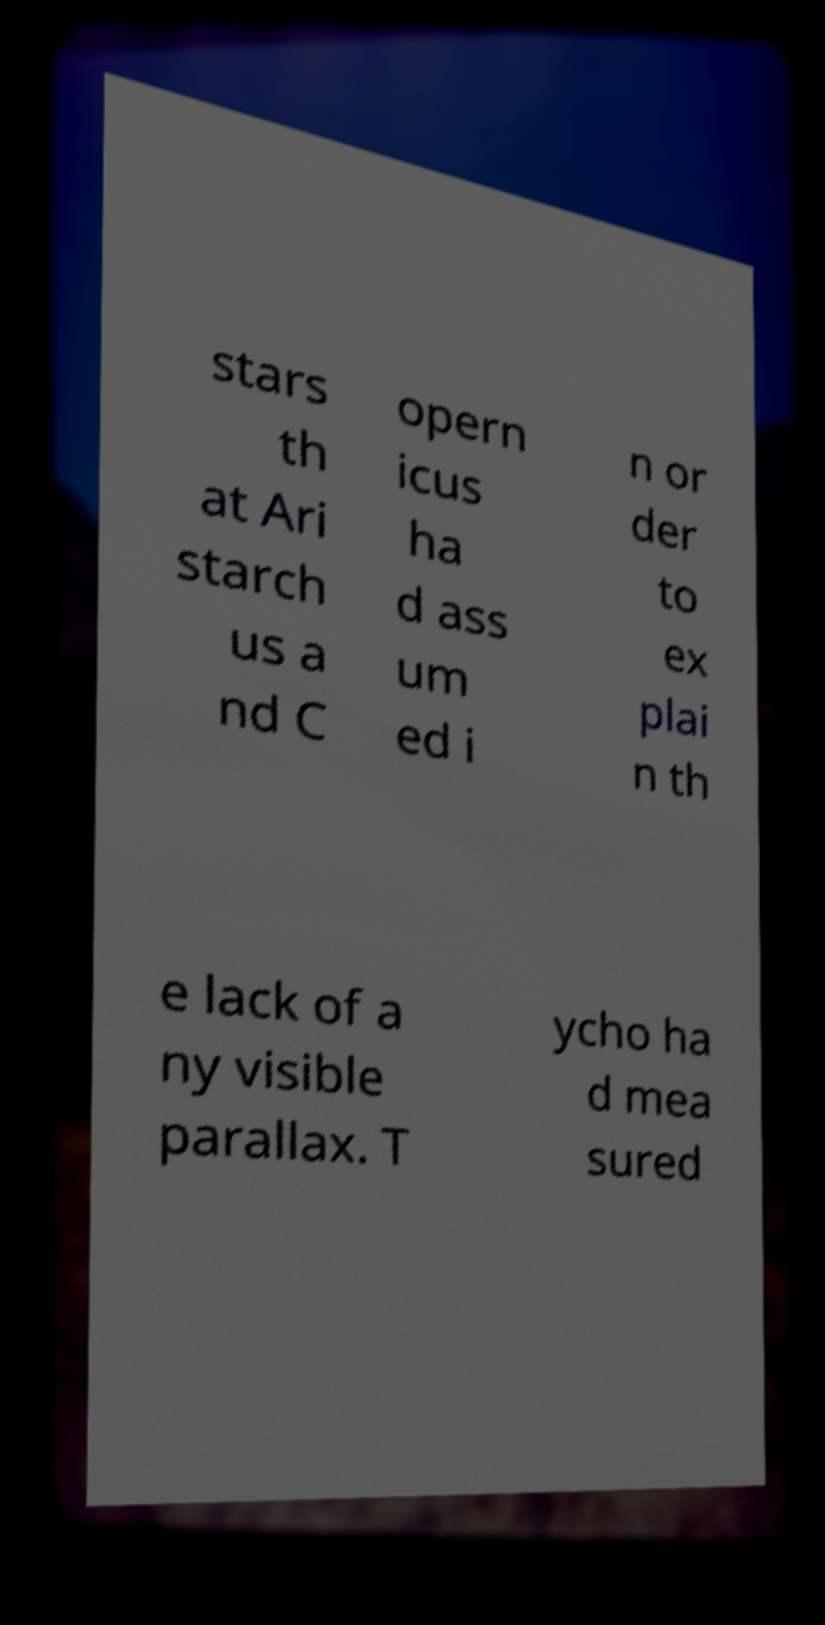What messages or text are displayed in this image? I need them in a readable, typed format. stars th at Ari starch us a nd C opern icus ha d ass um ed i n or der to ex plai n th e lack of a ny visible parallax. T ycho ha d mea sured 